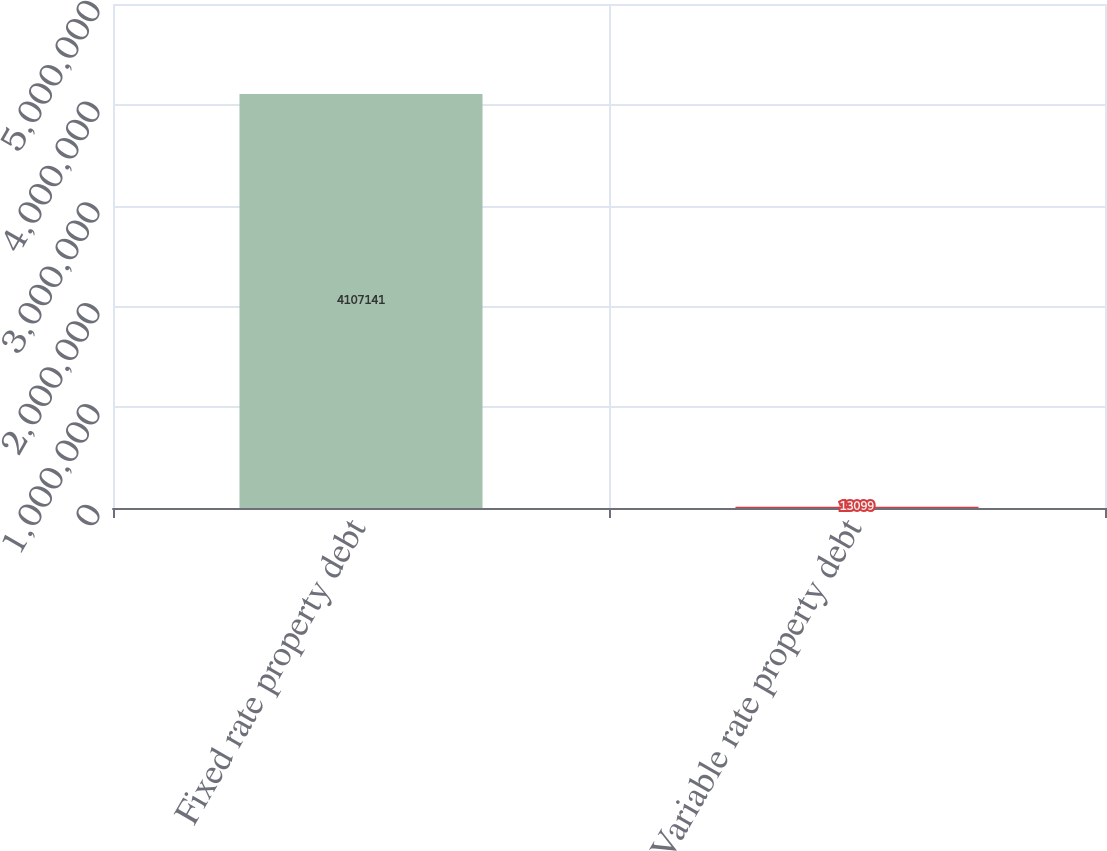Convert chart to OTSL. <chart><loc_0><loc_0><loc_500><loc_500><bar_chart><fcel>Fixed rate property debt<fcel>Variable rate property debt<nl><fcel>4.10714e+06<fcel>13099<nl></chart> 